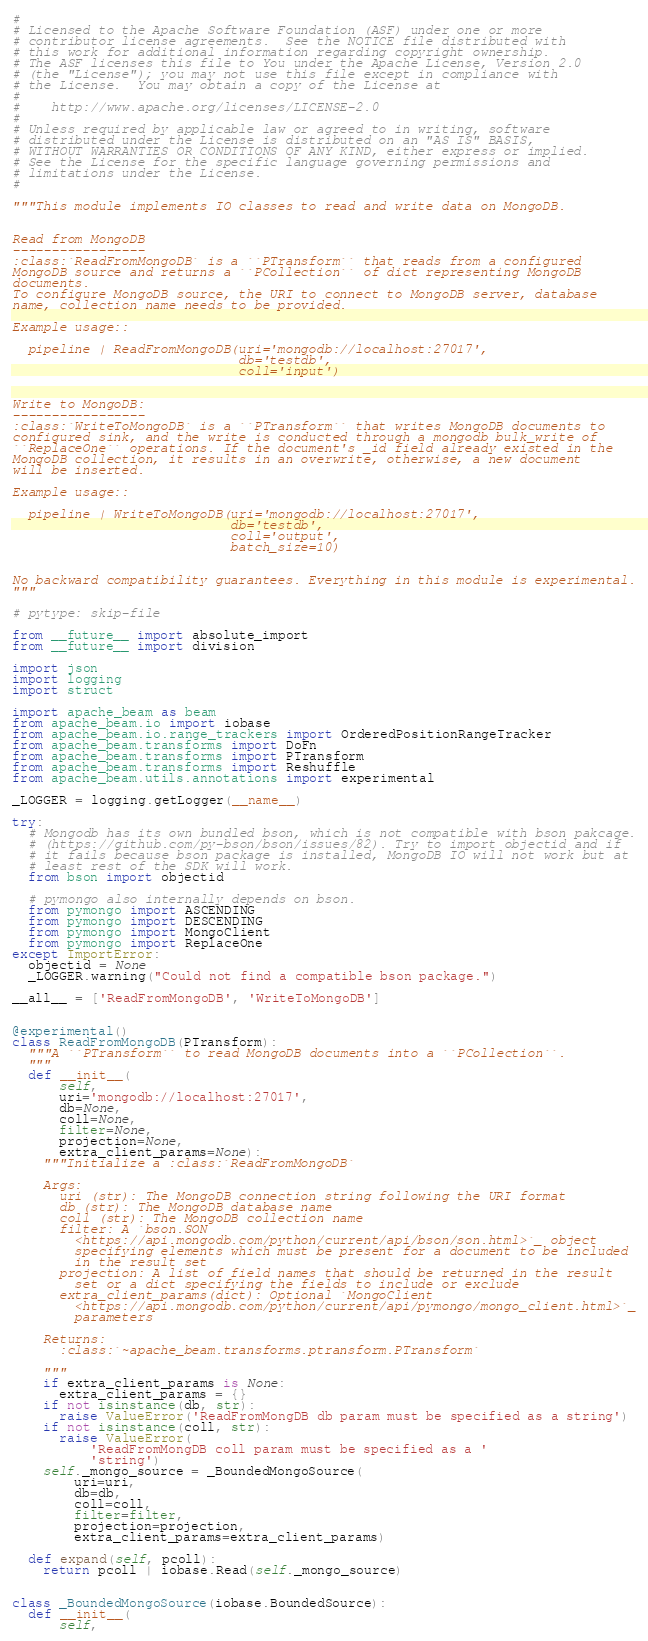<code> <loc_0><loc_0><loc_500><loc_500><_Python_>#
# Licensed to the Apache Software Foundation (ASF) under one or more
# contributor license agreements.  See the NOTICE file distributed with
# this work for additional information regarding copyright ownership.
# The ASF licenses this file to You under the Apache License, Version 2.0
# (the "License"); you may not use this file except in compliance with
# the License.  You may obtain a copy of the License at
#
#    http://www.apache.org/licenses/LICENSE-2.0
#
# Unless required by applicable law or agreed to in writing, software
# distributed under the License is distributed on an "AS IS" BASIS,
# WITHOUT WARRANTIES OR CONDITIONS OF ANY KIND, either express or implied.
# See the License for the specific language governing permissions and
# limitations under the License.
#

"""This module implements IO classes to read and write data on MongoDB.


Read from MongoDB
-----------------
:class:`ReadFromMongoDB` is a ``PTransform`` that reads from a configured
MongoDB source and returns a ``PCollection`` of dict representing MongoDB
documents.
To configure MongoDB source, the URI to connect to MongoDB server, database
name, collection name needs to be provided.

Example usage::

  pipeline | ReadFromMongoDB(uri='mongodb://localhost:27017',
                             db='testdb',
                             coll='input')


Write to MongoDB:
-----------------
:class:`WriteToMongoDB` is a ``PTransform`` that writes MongoDB documents to
configured sink, and the write is conducted through a mongodb bulk_write of
``ReplaceOne`` operations. If the document's _id field already existed in the
MongoDB collection, it results in an overwrite, otherwise, a new document
will be inserted.

Example usage::

  pipeline | WriteToMongoDB(uri='mongodb://localhost:27017',
                            db='testdb',
                            coll='output',
                            batch_size=10)


No backward compatibility guarantees. Everything in this module is experimental.
"""

# pytype: skip-file

from __future__ import absolute_import
from __future__ import division

import json
import logging
import struct

import apache_beam as beam
from apache_beam.io import iobase
from apache_beam.io.range_trackers import OrderedPositionRangeTracker
from apache_beam.transforms import DoFn
from apache_beam.transforms import PTransform
from apache_beam.transforms import Reshuffle
from apache_beam.utils.annotations import experimental

_LOGGER = logging.getLogger(__name__)

try:
  # Mongodb has its own bundled bson, which is not compatible with bson pakcage.
  # (https://github.com/py-bson/bson/issues/82). Try to import objectid and if
  # it fails because bson package is installed, MongoDB IO will not work but at
  # least rest of the SDK will work.
  from bson import objectid

  # pymongo also internally depends on bson.
  from pymongo import ASCENDING
  from pymongo import DESCENDING
  from pymongo import MongoClient
  from pymongo import ReplaceOne
except ImportError:
  objectid = None
  _LOGGER.warning("Could not find a compatible bson package.")

__all__ = ['ReadFromMongoDB', 'WriteToMongoDB']


@experimental()
class ReadFromMongoDB(PTransform):
  """A ``PTransform`` to read MongoDB documents into a ``PCollection``.
  """
  def __init__(
      self,
      uri='mongodb://localhost:27017',
      db=None,
      coll=None,
      filter=None,
      projection=None,
      extra_client_params=None):
    """Initialize a :class:`ReadFromMongoDB`

    Args:
      uri (str): The MongoDB connection string following the URI format
      db (str): The MongoDB database name
      coll (str): The MongoDB collection name
      filter: A `bson.SON
        <https://api.mongodb.com/python/current/api/bson/son.html>`_ object
        specifying elements which must be present for a document to be included
        in the result set
      projection: A list of field names that should be returned in the result
        set or a dict specifying the fields to include or exclude
      extra_client_params(dict): Optional `MongoClient
        <https://api.mongodb.com/python/current/api/pymongo/mongo_client.html>`_
        parameters

    Returns:
      :class:`~apache_beam.transforms.ptransform.PTransform`

    """
    if extra_client_params is None:
      extra_client_params = {}
    if not isinstance(db, str):
      raise ValueError('ReadFromMongDB db param must be specified as a string')
    if not isinstance(coll, str):
      raise ValueError(
          'ReadFromMongDB coll param must be specified as a '
          'string')
    self._mongo_source = _BoundedMongoSource(
        uri=uri,
        db=db,
        coll=coll,
        filter=filter,
        projection=projection,
        extra_client_params=extra_client_params)

  def expand(self, pcoll):
    return pcoll | iobase.Read(self._mongo_source)


class _BoundedMongoSource(iobase.BoundedSource):
  def __init__(
      self,</code> 